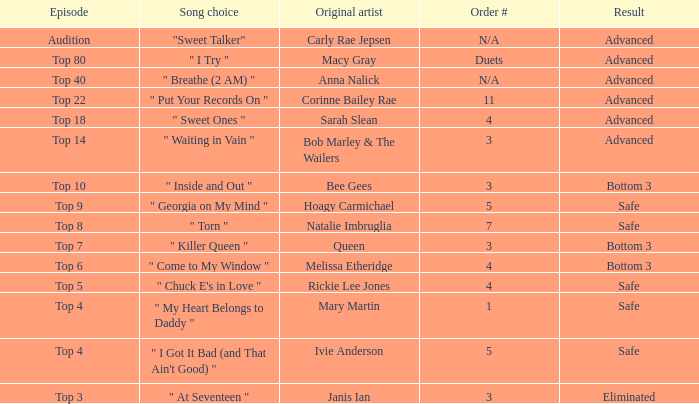What's the original artist of the song performed in the top 3 episode? Janis Ian. 